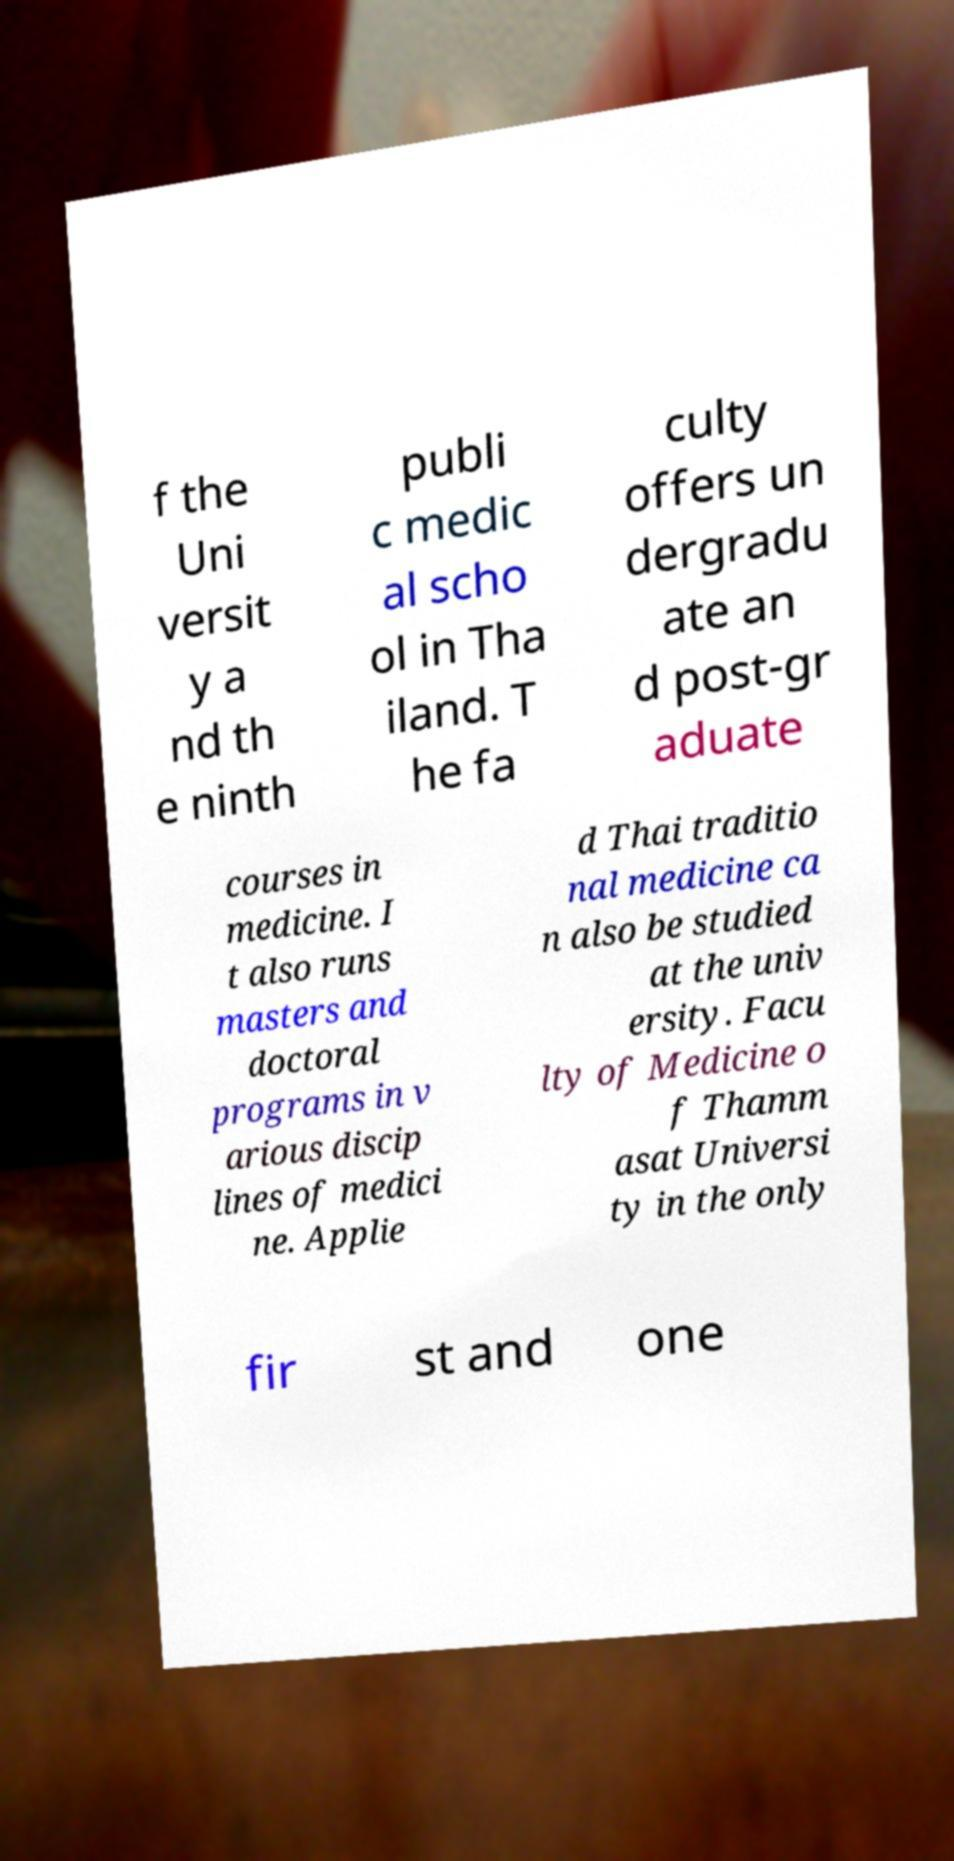Please read and relay the text visible in this image. What does it say? f the Uni versit y a nd th e ninth publi c medic al scho ol in Tha iland. T he fa culty offers un dergradu ate an d post-gr aduate courses in medicine. I t also runs masters and doctoral programs in v arious discip lines of medici ne. Applie d Thai traditio nal medicine ca n also be studied at the univ ersity. Facu lty of Medicine o f Thamm asat Universi ty in the only fir st and one 